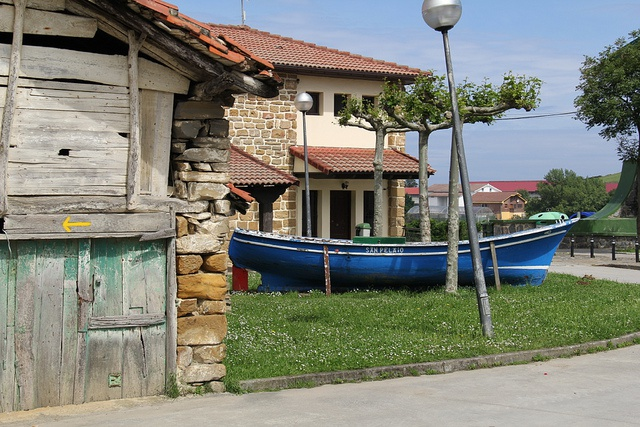Describe the objects in this image and their specific colors. I can see a boat in gray, black, navy, blue, and darkgray tones in this image. 